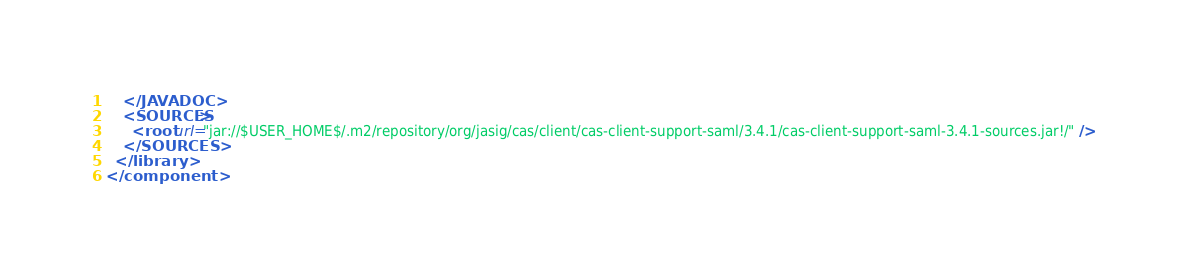Convert code to text. <code><loc_0><loc_0><loc_500><loc_500><_XML_>    </JAVADOC>
    <SOURCES>
      <root url="jar://$USER_HOME$/.m2/repository/org/jasig/cas/client/cas-client-support-saml/3.4.1/cas-client-support-saml-3.4.1-sources.jar!/" />
    </SOURCES>
  </library>
</component></code> 